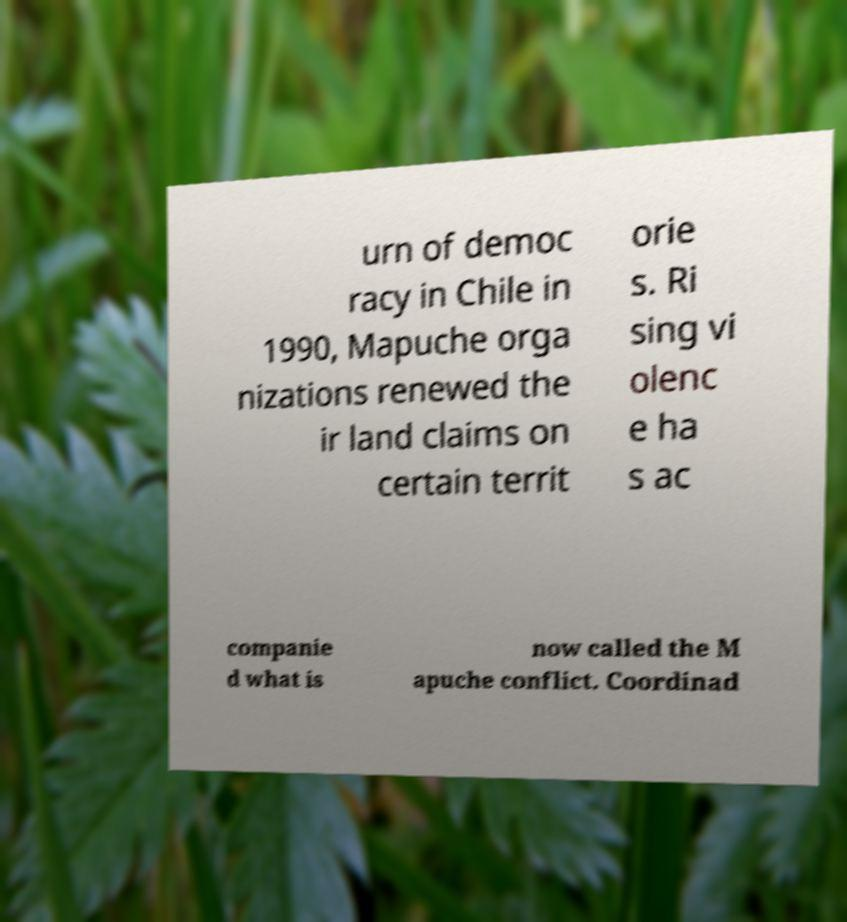Could you extract and type out the text from this image? urn of democ racy in Chile in 1990, Mapuche orga nizations renewed the ir land claims on certain territ orie s. Ri sing vi olenc e ha s ac companie d what is now called the M apuche conflict. Coordinad 